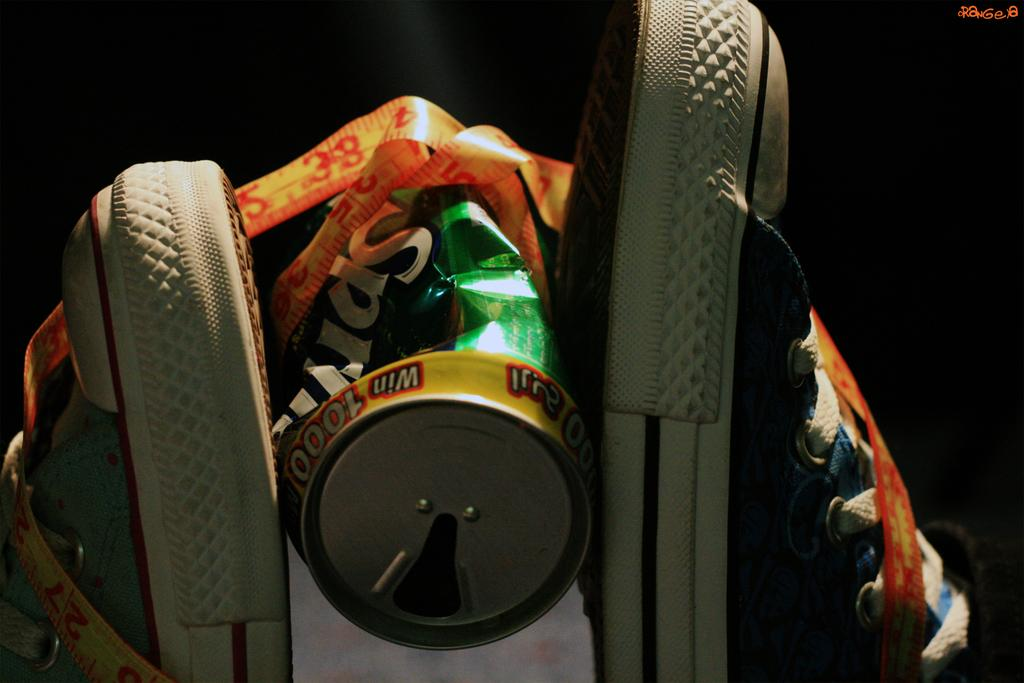What color is the tin that is visible in the image? The tin in the image is green. What type of footwear can be seen in the image? There is a pair of shoes in the image. What type of adhesive material is present in the image? There is a tape in the image. What is the color of the background in the image? The background of the image is dark. What type of breakfast is being prepared in the image? There is no indication of breakfast or any food preparation in the image. What type of tools might a carpenter use that are present in the image? There are no carpentry tools present in the image. Are there any bears visible in the image? There are no bears present in the image. 